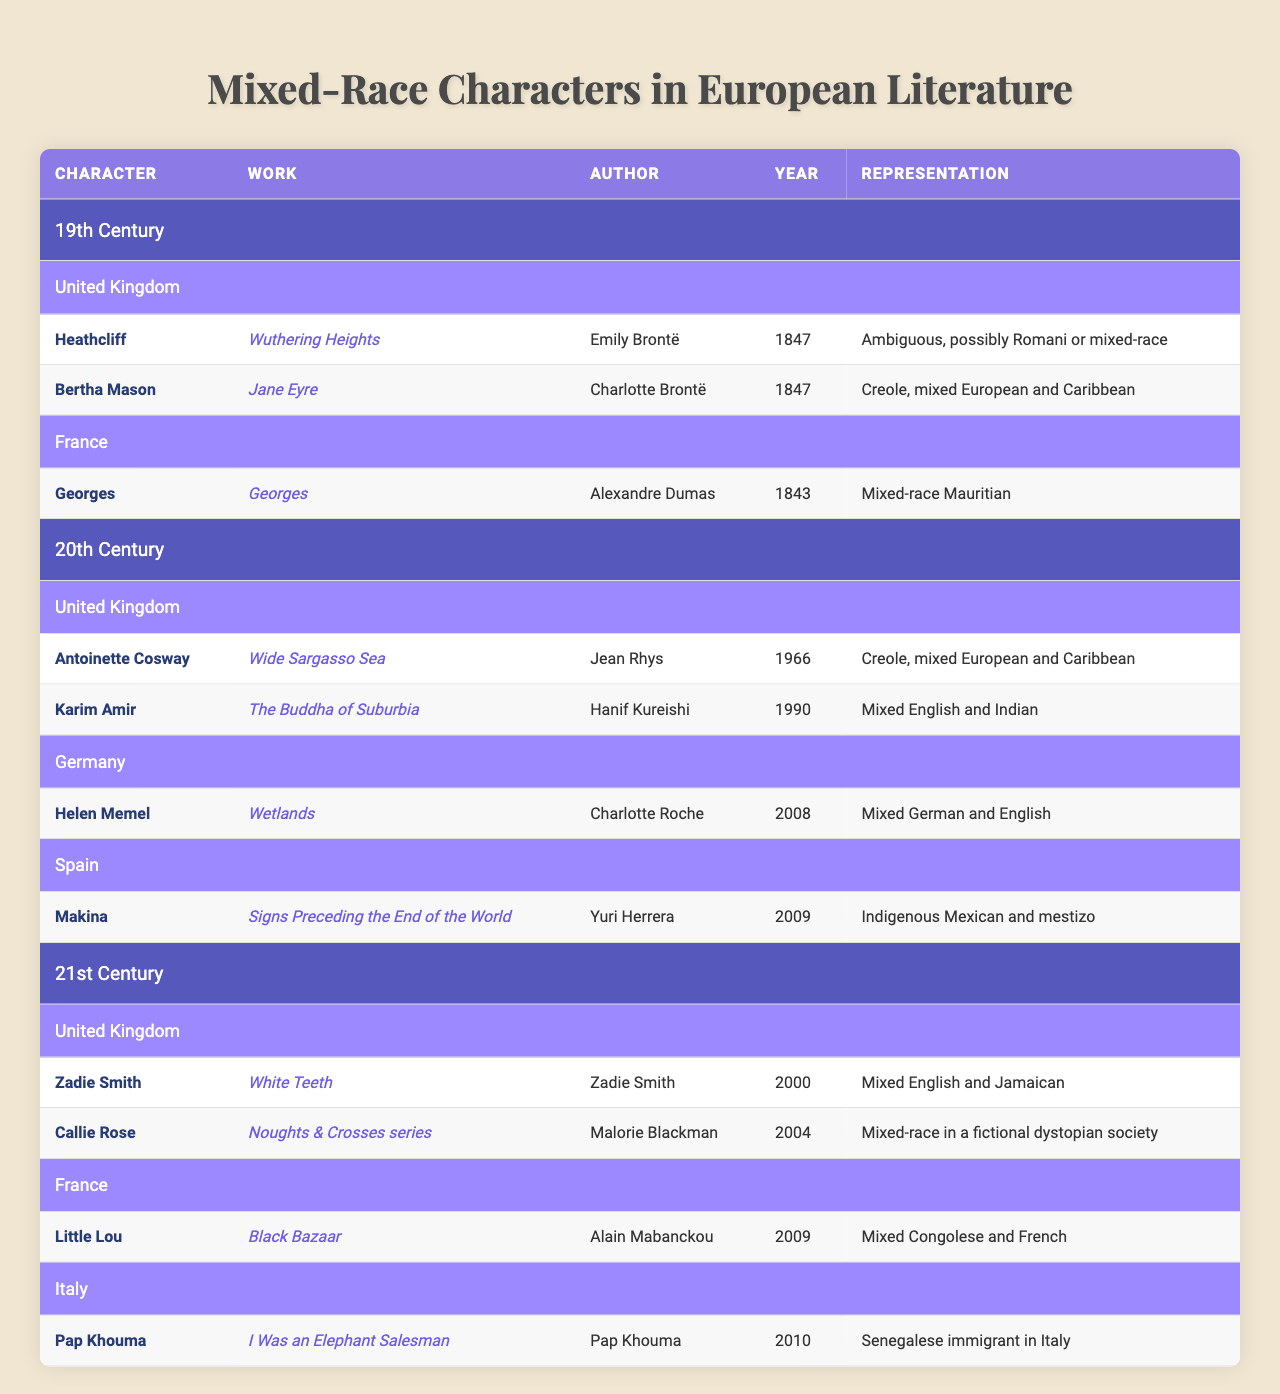What mixed-race character from the 19th Century is featured in a work by Charlotte Brontë? The table shows that Bertha Mason is the mixed-race character featured in "Jane Eyre," authored by Charlotte Brontë in 1847.
Answer: Bertha Mason Which character is represented as a mixed-race Mauritian in the 19th Century? The table lists Georges from the work "Georges" by Alexandre Dumas, published in 1843, as a mixed-race Mauritian character.
Answer: Georges How many mixed-race characters are listed for the 20th Century in the United Kingdom? In the United Kingdom's section for the 20th Century, there are two characters: Antoinette Cosway and Karim Amir, thus the total is two.
Answer: 2 Which country has a mixed-race character named Callie Rose, and in which century is she featured? Callie Rose is from the United Kingdom and appears in the 21st Century, as indicated in the table.
Answer: United Kingdom, 21st Century Is there any character in the table that is identified as Creole? Yes, both Bertha Mason from the 19th Century and Antoinette Cosway from the 20th Century are identified as Creole characters.
Answer: Yes Which character has the most recent year of publication, and what is that year? The most recent publication year in the table is 2010 for the character Pap Khouma from "I Was an Elephant Salesman."
Answer: 2010 Calculate the total number of characters listed per century in the table. In the 19th Century, there are 3 characters; in the 20th Century, there are 3 characters; and in the 21st Century, there are 3 characters. Adding them gives a total of 9 characters across all centuries.
Answer: 9 How many characters are represented from Spain across all centuries? The table indicates there is one character from Spain, named Makina from the 20th Century.
Answer: 1 Which century has the highest diversity of mixed-race representations based on the number of characters? Analyzing the table, each century has 3 characters, so there is no single century with higher diversity; they are equal.
Answer: None, they are equal What character represents mixed English and Indian heritage and in which work does he appear? The character Karim Amir represents mixed English and Indian heritage and appears in the work "The Buddha of Suburbia."
Answer: Karim Amir, "The Buddha of Suburbia" 